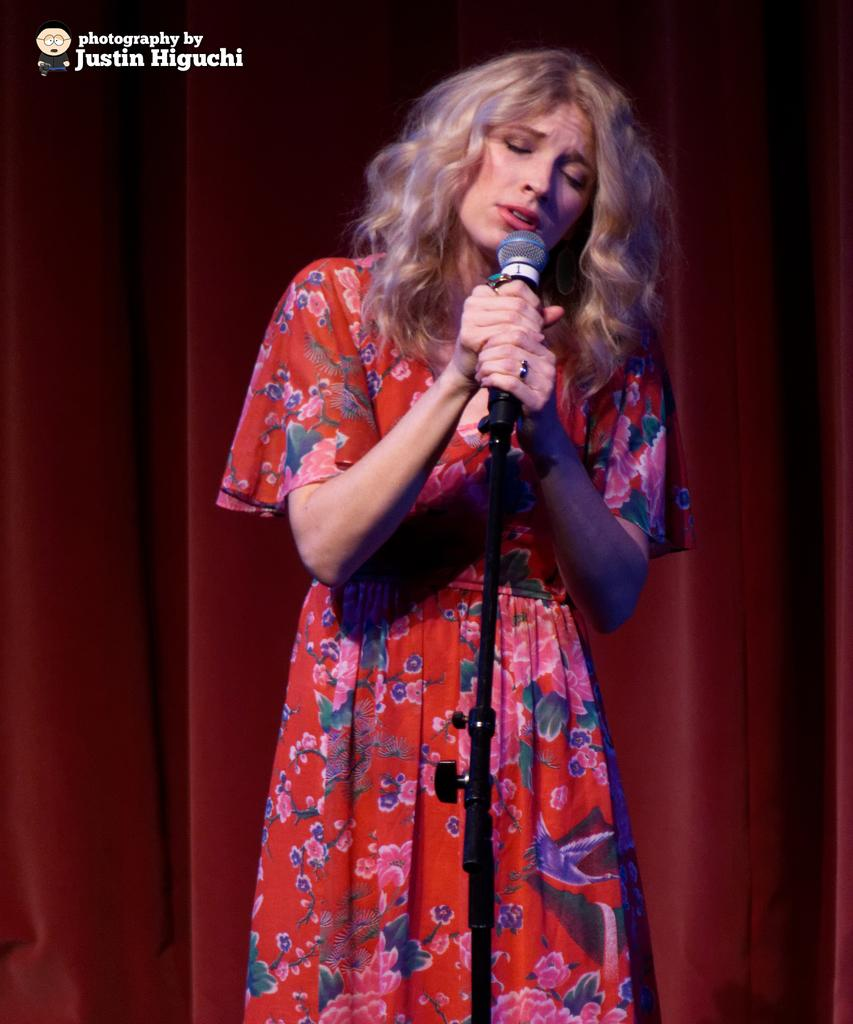Who is the main subject in the image? There is a woman in the image. What is the woman doing in the image? The woman is singing. What object is the woman holding in the image? The woman is holding a microphone. What type of ink is being used by the woman in the image? There is no ink present in the image, as the woman is singing and holding a microphone. 